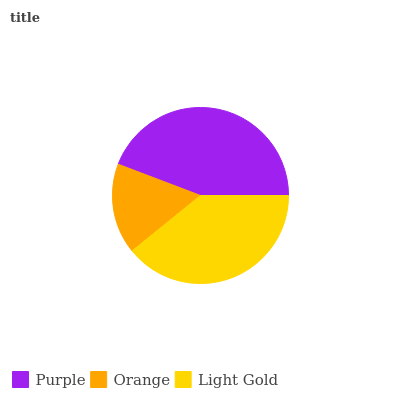Is Orange the minimum?
Answer yes or no. Yes. Is Purple the maximum?
Answer yes or no. Yes. Is Light Gold the minimum?
Answer yes or no. No. Is Light Gold the maximum?
Answer yes or no. No. Is Light Gold greater than Orange?
Answer yes or no. Yes. Is Orange less than Light Gold?
Answer yes or no. Yes. Is Orange greater than Light Gold?
Answer yes or no. No. Is Light Gold less than Orange?
Answer yes or no. No. Is Light Gold the high median?
Answer yes or no. Yes. Is Light Gold the low median?
Answer yes or no. Yes. Is Orange the high median?
Answer yes or no. No. Is Purple the low median?
Answer yes or no. No. 